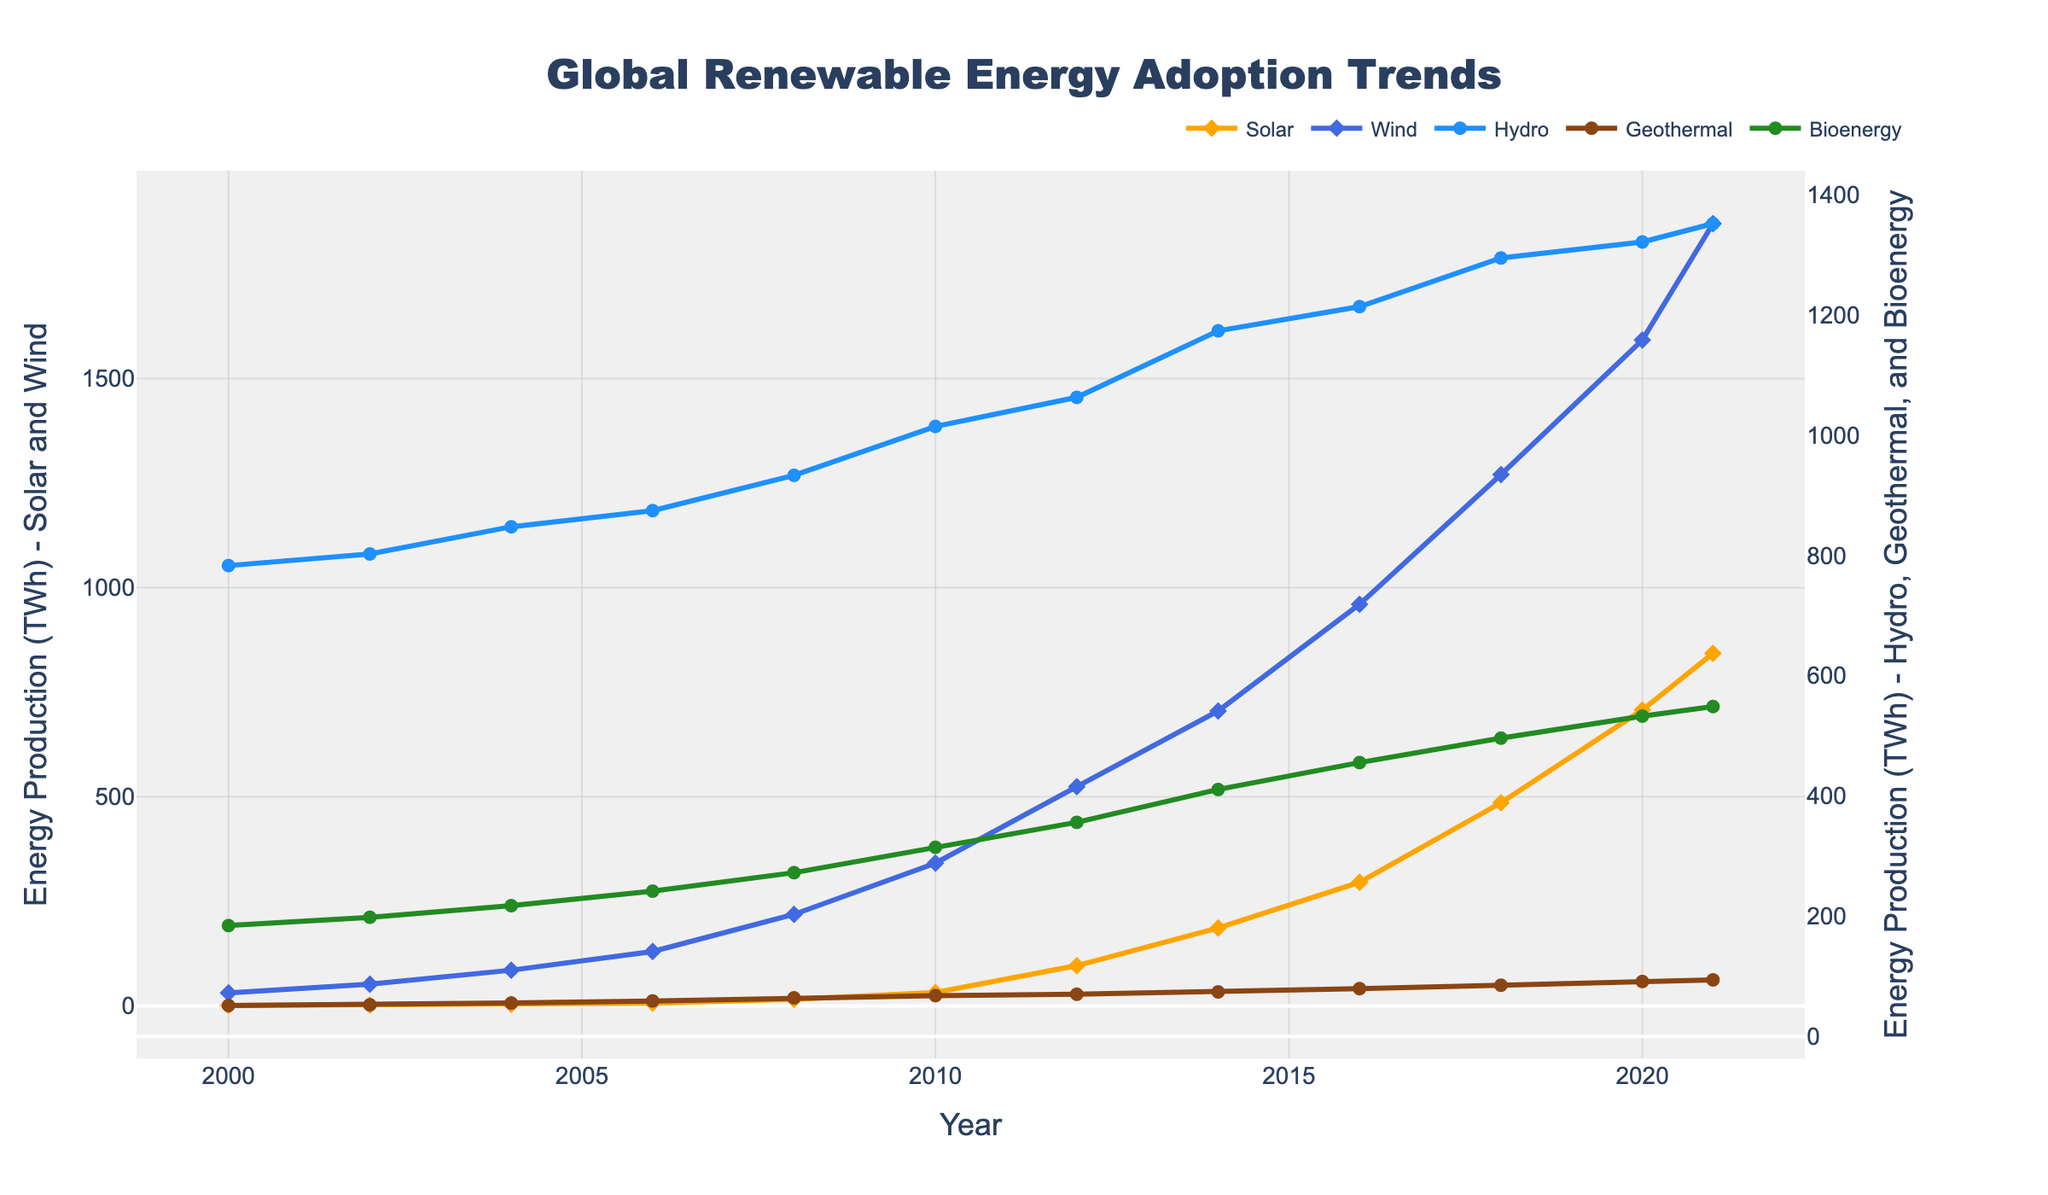Which renewable energy type had the highest production in 2000? Look at the values for each energy type in 2000. Hydro had the highest value at 783.1 TWh.
Answer: Hydro What year did solar energy surpass 100 TWh? Check the solar energy values year by year. In 2012, solar energy production was 96.5 TWh, and it increased to 186.5 TWh in 2014. Therefore, solar surpassed 100 TWh in 2014.
Answer: 2014 How does the trend of wind energy production compare to that of bioenergy from 2000 to 2021? Both wind and bioenergy show an upwards trend from 2000 to 2021, but wind energy increases at a much higher rate and surpasses bioenergy in 2006. By 2021, wind energy production is significantly higher than bioenergy. Wind production starts at 31.5 TWh in 2000 and ends at 1870.3 TWh in 2021, while bioenergy starts at 184.5 TWh and ends at 548.7 TWh.
Answer: Wind energy increased at a much higher rate than bioenergy Which two energy types had the least production increase from 2000 to 2021? Calculate the difference between 2021 and 2000 values for each energy type. Geothermal increased from 51.6 TWh to 94.2 TWh (an increase of 42.6 TWh), and Hydro increased from 783.1 TWh to 1351.7 TWh (an increase of 568.6 TWh). These are the smallest increases compared to other energy types.
Answer: Geothermal and Hydro Which energy type had the most significant growth between two consecutive years? Identify differences between subsequent years for each energy type. Solar energy between 2010 and 2012 grew from 32.2 TWh to 96.5 TWh, an increase of 64.3 TWh, which appears to be the most significant growth in this dataset.
Answer: Solar energy (2010-2012) In 2018, which non-solar energy produced the most energy out of wind, hydro, geothermal, and bioenergy? Compare the 2018 values of wind (1270.4 TWh), hydro (1294.6 TWh), geothermal (85.3 TWh), and bioenergy (496.2 TWh). Hydro had the highest production among them.
Answer: Hydro What is the average annual growth rate of wind energy from 2000 to 2021? Calculate the growth of wind energy from 31.5 TWh in 2000 to 1870.3 TWh in 2021. The average annual growth rate can be computed as (final_value/initial_value)^(1/number_of_years) - 1. The number of years is 21 (2021-2000). Therefore, (1870.3/31.5)^(1/21) - 1 ≈ 0.187 or 18.7%.
Answer: 18.7% Which energy types appear to have similar growth patterns? Visually compare the trends of the lines representing different energy types. Solar and wind appear to have steep and exponential-like growth patterns, while geothermal, hydro, and bioenergy have more linear growth patterns.
Answer: Solar and Wind In which year did bioenergy production surpass 500 TWh? Look at the bioenergy values year by year. Bioenergy production reached 532.8 TWh in 2020, which is the first year it surpasses 500 TWh.
Answer: 2020 